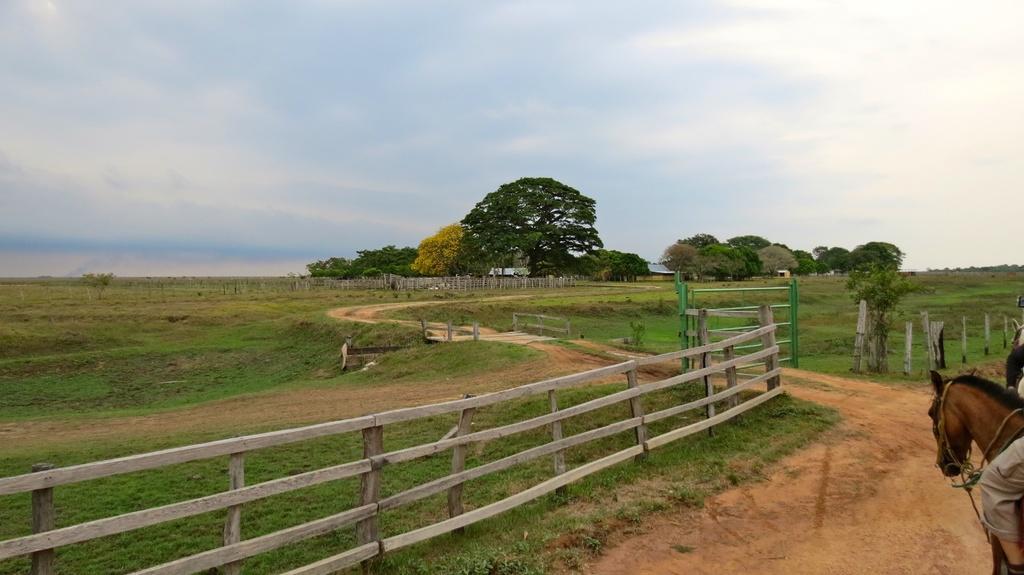How would you summarize this image in a sentence or two? In this image we can see a leg of a person on the horse, there is a fencing, trees, also we can see the sky. 